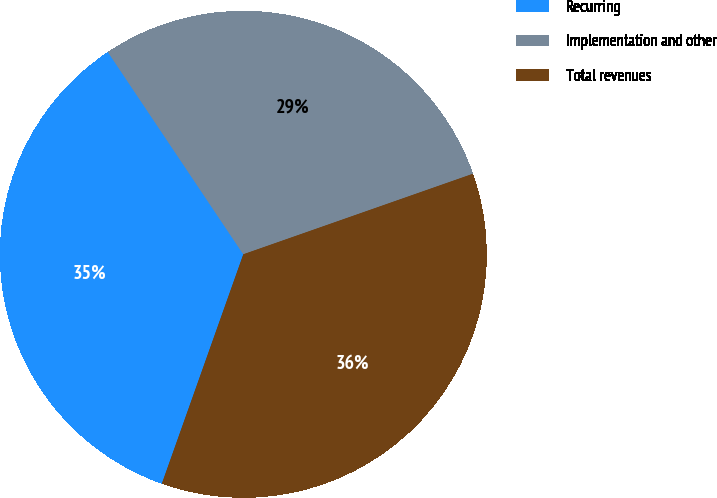Convert chart. <chart><loc_0><loc_0><loc_500><loc_500><pie_chart><fcel>Recurring<fcel>Implementation and other<fcel>Total revenues<nl><fcel>35.18%<fcel>29.02%<fcel>35.8%<nl></chart> 